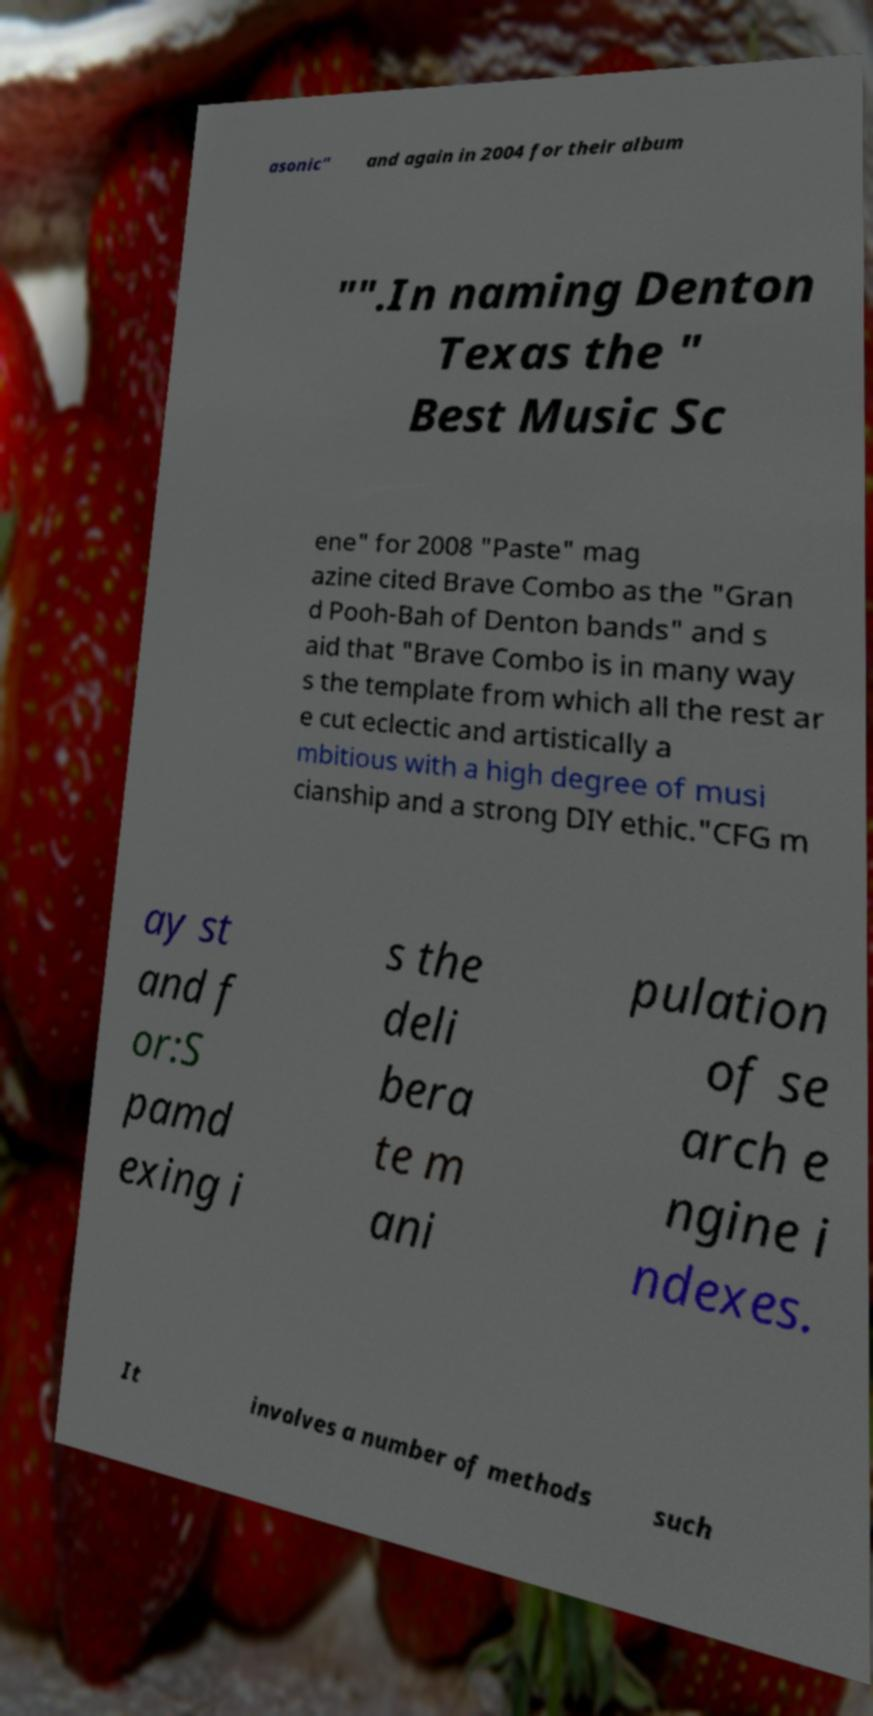Please identify and transcribe the text found in this image. asonic" and again in 2004 for their album "".In naming Denton Texas the " Best Music Sc ene" for 2008 "Paste" mag azine cited Brave Combo as the "Gran d Pooh-Bah of Denton bands" and s aid that "Brave Combo is in many way s the template from which all the rest ar e cut eclectic and artistically a mbitious with a high degree of musi cianship and a strong DIY ethic."CFG m ay st and f or:S pamd exing i s the deli bera te m ani pulation of se arch e ngine i ndexes. It involves a number of methods such 